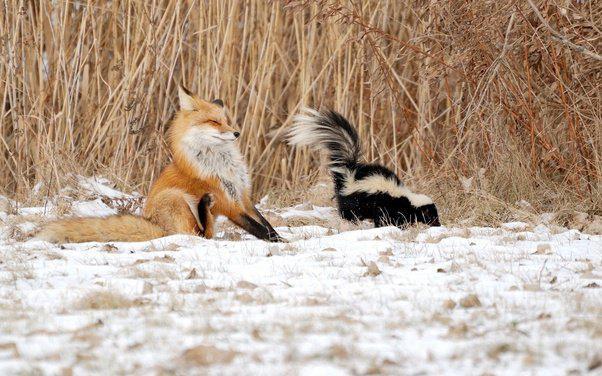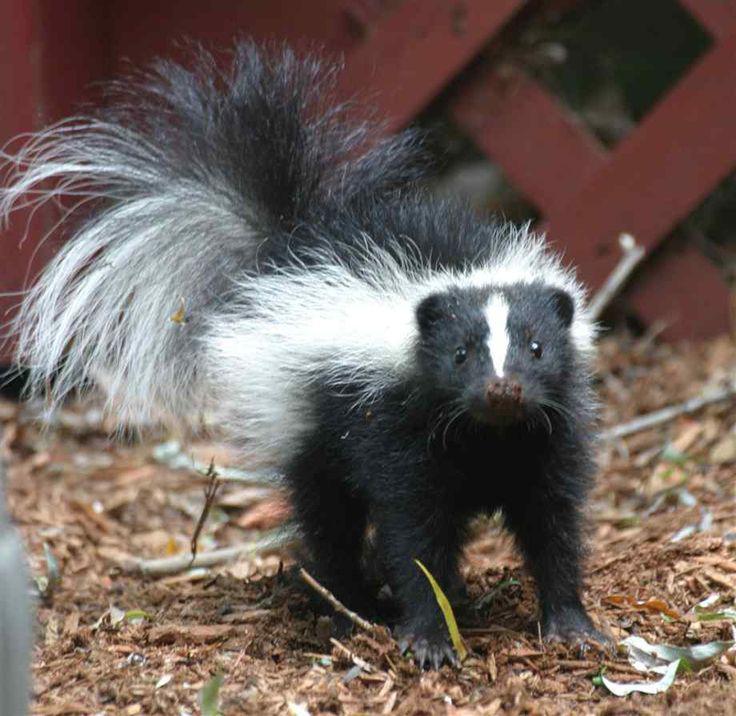The first image is the image on the left, the second image is the image on the right. Examine the images to the left and right. Is the description "The left image shows a reddish-brown canine facing the tail end of a skunk, and the right image features one solitary skunk that is not in profile." accurate? Answer yes or no. Yes. The first image is the image on the left, the second image is the image on the right. Analyze the images presented: Is the assertion "In the left image there is a skunk and one other animal." valid? Answer yes or no. Yes. 